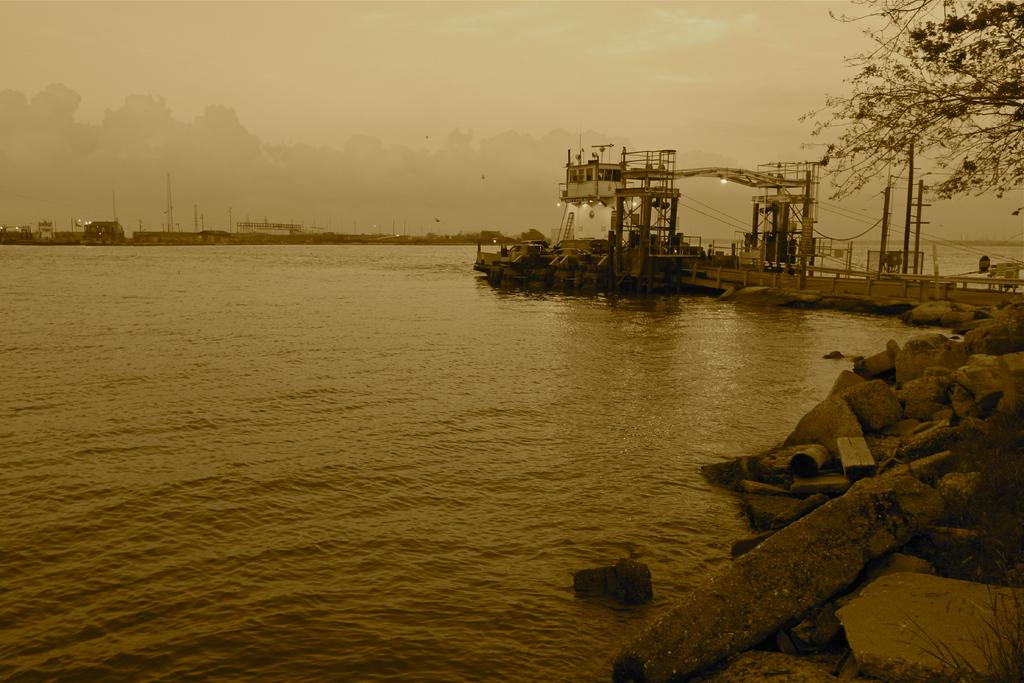What type of natural body of water is present in the image? There is an ocean in the image. What can be seen on the ground in the image? There are stones visible in the image. What type of vegetation is present in the image? There are trees in the image. What is the condition of the sky in the image? The sky is cloudy in the image. What type of activity is taking place near the ocean in the image? There is construction on the side of the ocean in the image. Can you see a bird kicking a star in the image? No, there is no bird or star present in the image. 